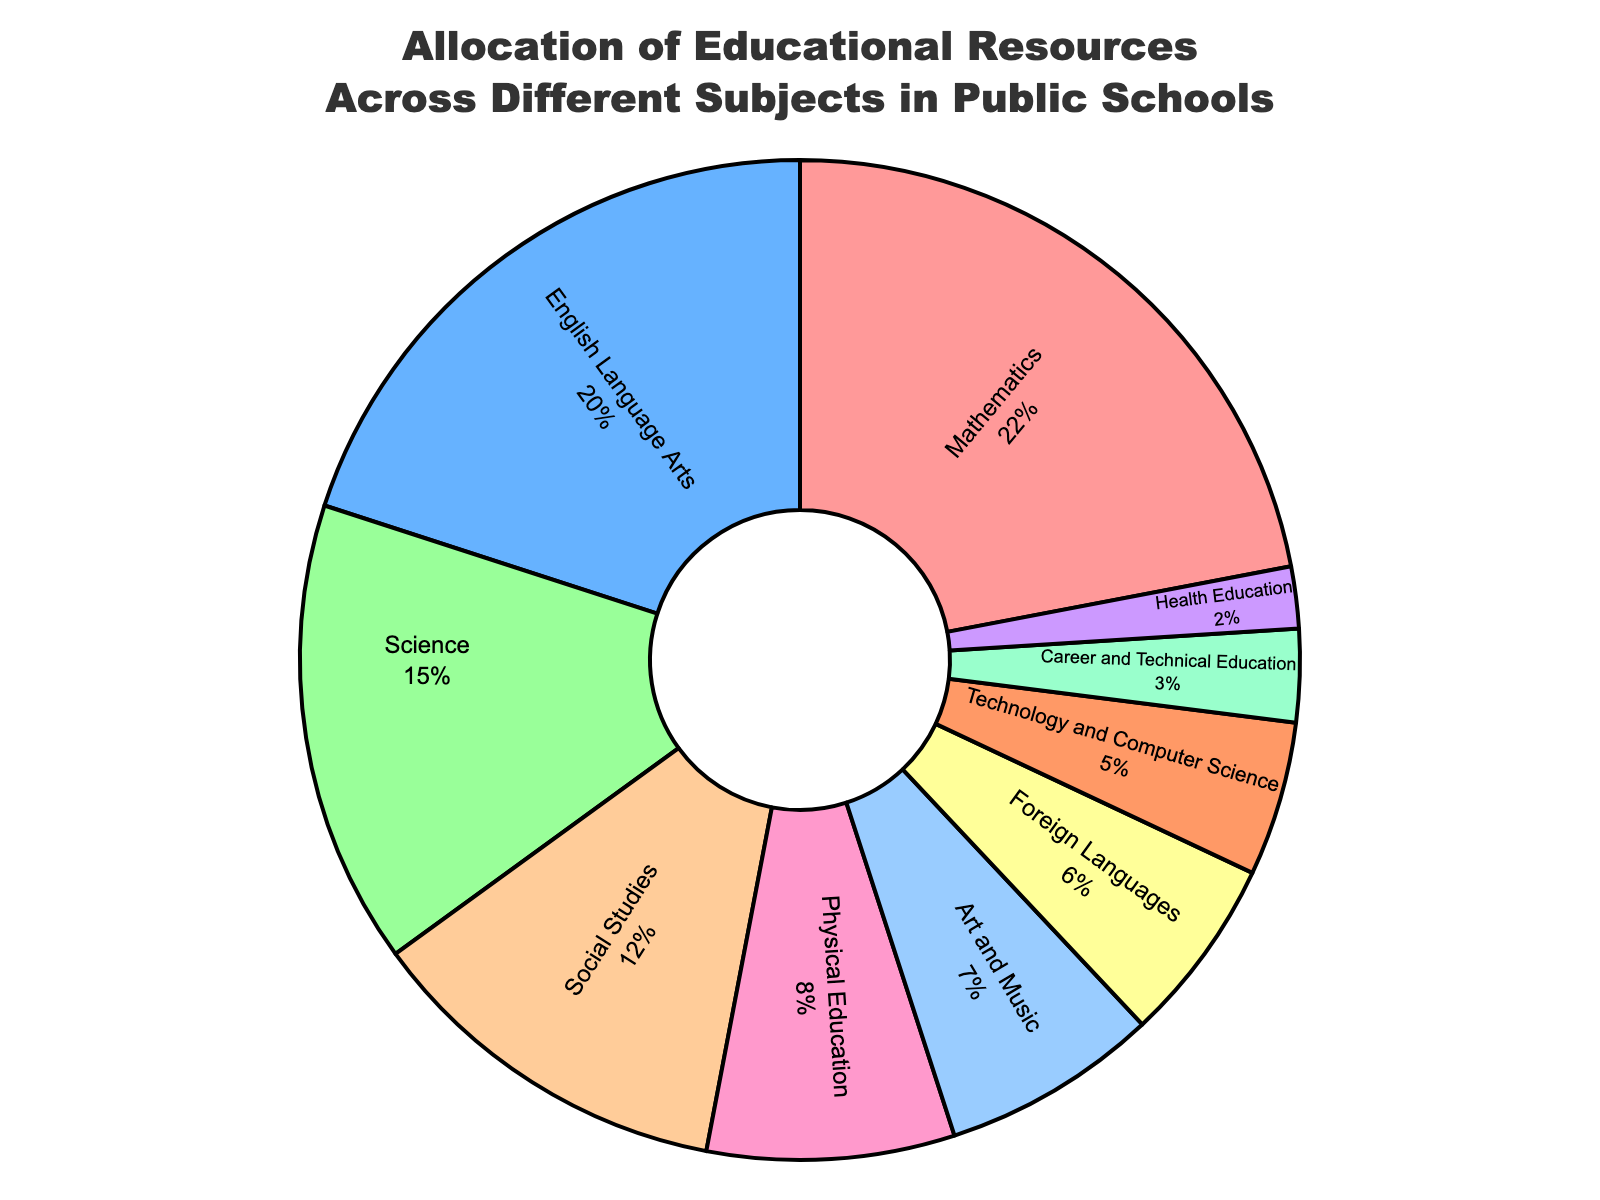What percentage of resources is allocated to Mathematics, English Language Arts, and Science combined? Sum the percentages of Mathematics, English Language Arts, and Science: 22% (Mathematics) + 20% (English Language Arts) + 15% (Science) = 57%
Answer: 57% Which subject receives more resources, Physical Education or Foreign Languages? Compare the percentages allocated to Physical Education and Foreign Languages: 8% (Physical Education) > 6% (Foreign Languages)
Answer: Physical Education What is the difference in resource allocation between the subject with the highest percentage and the subject with the lowest percentage? Identify the highest and lowest percentages: Mathematics at 22% and Health Education at 2%. The difference is calculated as 22% - 2% = 20%
Answer: 20% What color represents the resources allocated to Social Studies in the pie chart? Look for the color assigned to the 'Social Studies' section in the pie chart. In the code, Social Studies is represented by '#FFCC99' which is a shade of light brown.
Answer: Light brown How do the resources allocated to Art and Music compare to those allocated to Technology and Computer Science? Compare the percentages for Art and Music (7%) and Technology and Computer Science (5%). Art and Music have 2% more resources than Technology and Computer Science.
Answer: Art and Music have more resources by 2% What is the combined percentage of resources allocated to subjects outside of core academic subjects (Mathematics, English Language Arts, Science, and Social Studies)? Calculate the sum of the percentages for non-core subjects: Physical Education (8%) + Art and Music (7%) + Foreign Languages (6%) + Technology and Computer Science (5%) + Career and Technical Education (3%) + Health Education (2%) = 31%
Answer: 31% Which subject is allocated the least amount of resources, and what is the percentage? Identify the subject with the smallest percentage from the data provided. Health Education is allocated the least with 2%.
Answer: Health Education, 2% Are Foreign Languages allocated more or less resources than Art and Music? By how much? Compare the percentages for Foreign Languages (6%) and Art and Music (7%). Art and Music receive 1% more resources than Foreign Languages.
Answer: Less by 1% Is the allocation of resources to Science equal to, greater than, or less than the allocation to Social Studies and Physical Education combined? Sum the percentages for Social Studies and Physical Education: 12% (Social Studies) + 8% (Physical Education) = 20%. Compare this to Science’s 15%. Science receives less.
Answer: Less 